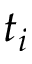Convert formula to latex. <formula><loc_0><loc_0><loc_500><loc_500>t _ { i }</formula> 